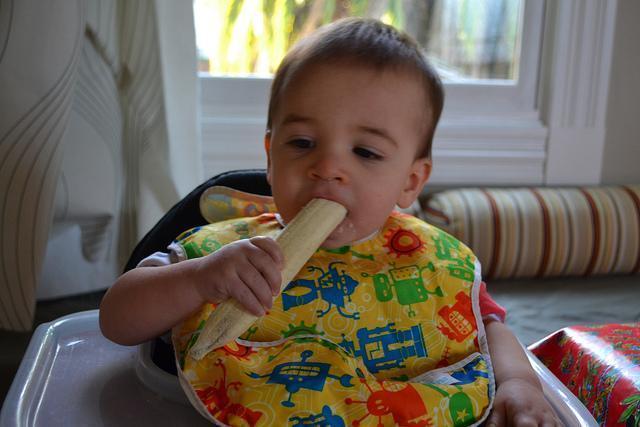Evaluate: Does the caption "The banana is at the right side of the person." match the image?
Answer yes or no. Yes. 